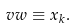<formula> <loc_0><loc_0><loc_500><loc_500>\ v w \equiv x _ { k } .</formula> 